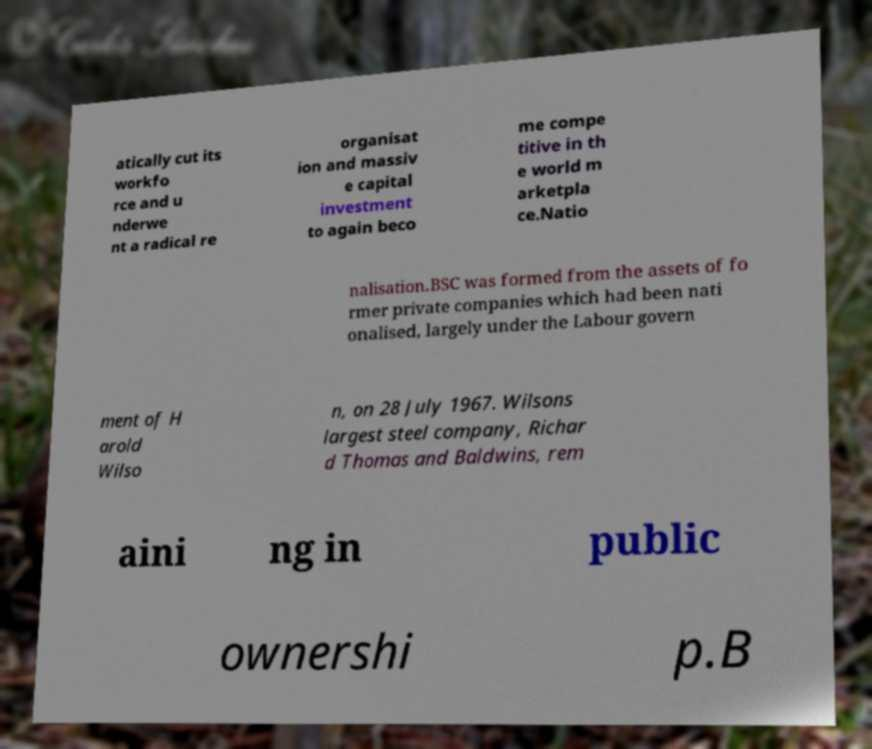What messages or text are displayed in this image? I need them in a readable, typed format. atically cut its workfo rce and u nderwe nt a radical re organisat ion and massiv e capital investment to again beco me compe titive in th e world m arketpla ce.Natio nalisation.BSC was formed from the assets of fo rmer private companies which had been nati onalised, largely under the Labour govern ment of H arold Wilso n, on 28 July 1967. Wilsons largest steel company, Richar d Thomas and Baldwins, rem aini ng in public ownershi p.B 